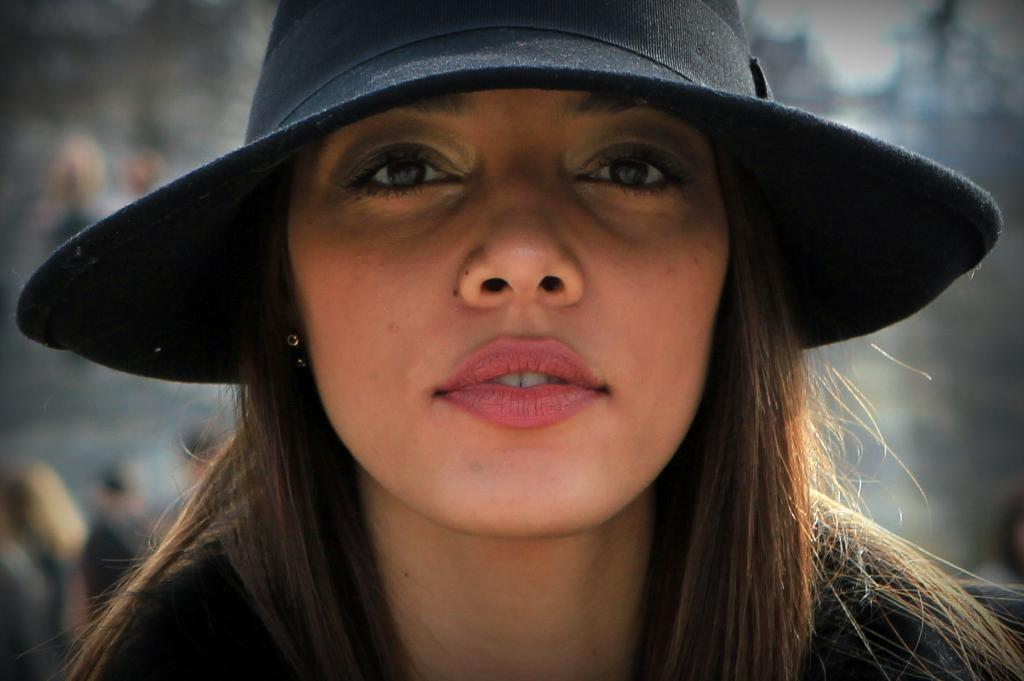Who is the main subject in the image? There is a woman in the image. What is the woman wearing on her head? The woman is wearing a black hat. Can you describe the background of the image? The background of the image is blurred. What type of stew is the woman eating in the image? There is no stew present in the image; the woman is not eating anything. 